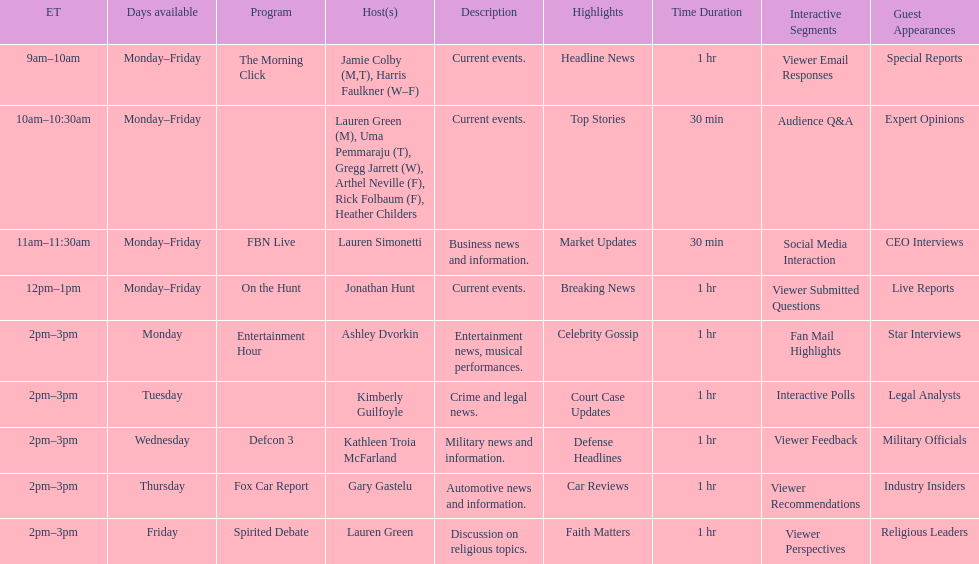Who has a show airing at 2 pm on fridays? Lauren Green. 